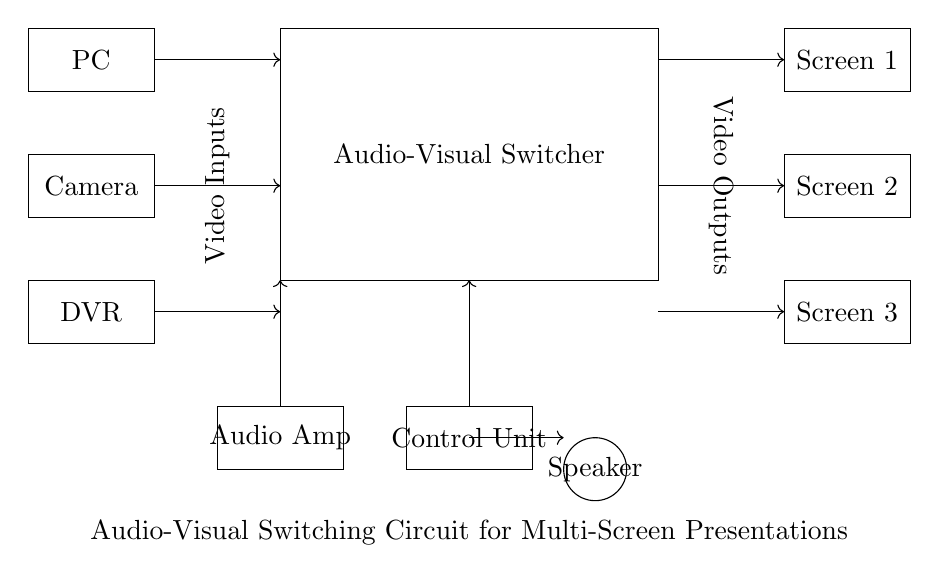What are the input sources in this circuit? The circuit diagram shows three input sources: a PC, a Camera, and a DVR. These are represented by the three rectangles on the left side of the diagram labeled accordingly.
Answer: PC, Camera, DVR How many output screens are connected? There are three output screens connected, as indicated by the three rectangles on the right side of the circuit labeled Screen 1, Screen 2, and Screen 3.
Answer: Three What is the function of the audio amplifier in this circuit? The audio amplifier is responsible for boosting the audio signal before it reaches the speaker. It is important for ensuring that the sound output is clear and at the appropriate volume level. This is located in the lower left section of the circuit diagram.
Answer: Boosting audio signal What role does the control unit play in this audio-visual switching circuit? The control unit directs which input source is selected for output to the screens and speaker, coordinating the switching operation. It is depicted as the rectangle in the middle below the main switcher block in the diagram and has an output connection pointing upwards to signify control of audio and video signals.
Answer: Directing source selection What does the arrow connection from the control unit indicate? The arrow connection from the control unit signifies the flow of control signals or data that manage the switching of inputs to the outputs, ensuring that selected sources are routed to the correct screens or audio output. It is crucial for the proper functioning of the audio-visual setup.
Answer: Flow of control signals Which component is responsible for the sound output? The speaker is responsible for the sound output as shown in the circuit diagram by the circle labeled as Speaker. It receives amplified audio signals and produces sound.
Answer: Speaker What is located at the bottom of the circuit block? At the bottom of the circuit diagram, there is a label describing the circuit, which indicates that this is an audio-visual switching circuit intended for multi-screen presentations. This serves as a title for clarity on the system's application.
Answer: Audio-visual switching circuit for multi-screen presentations 